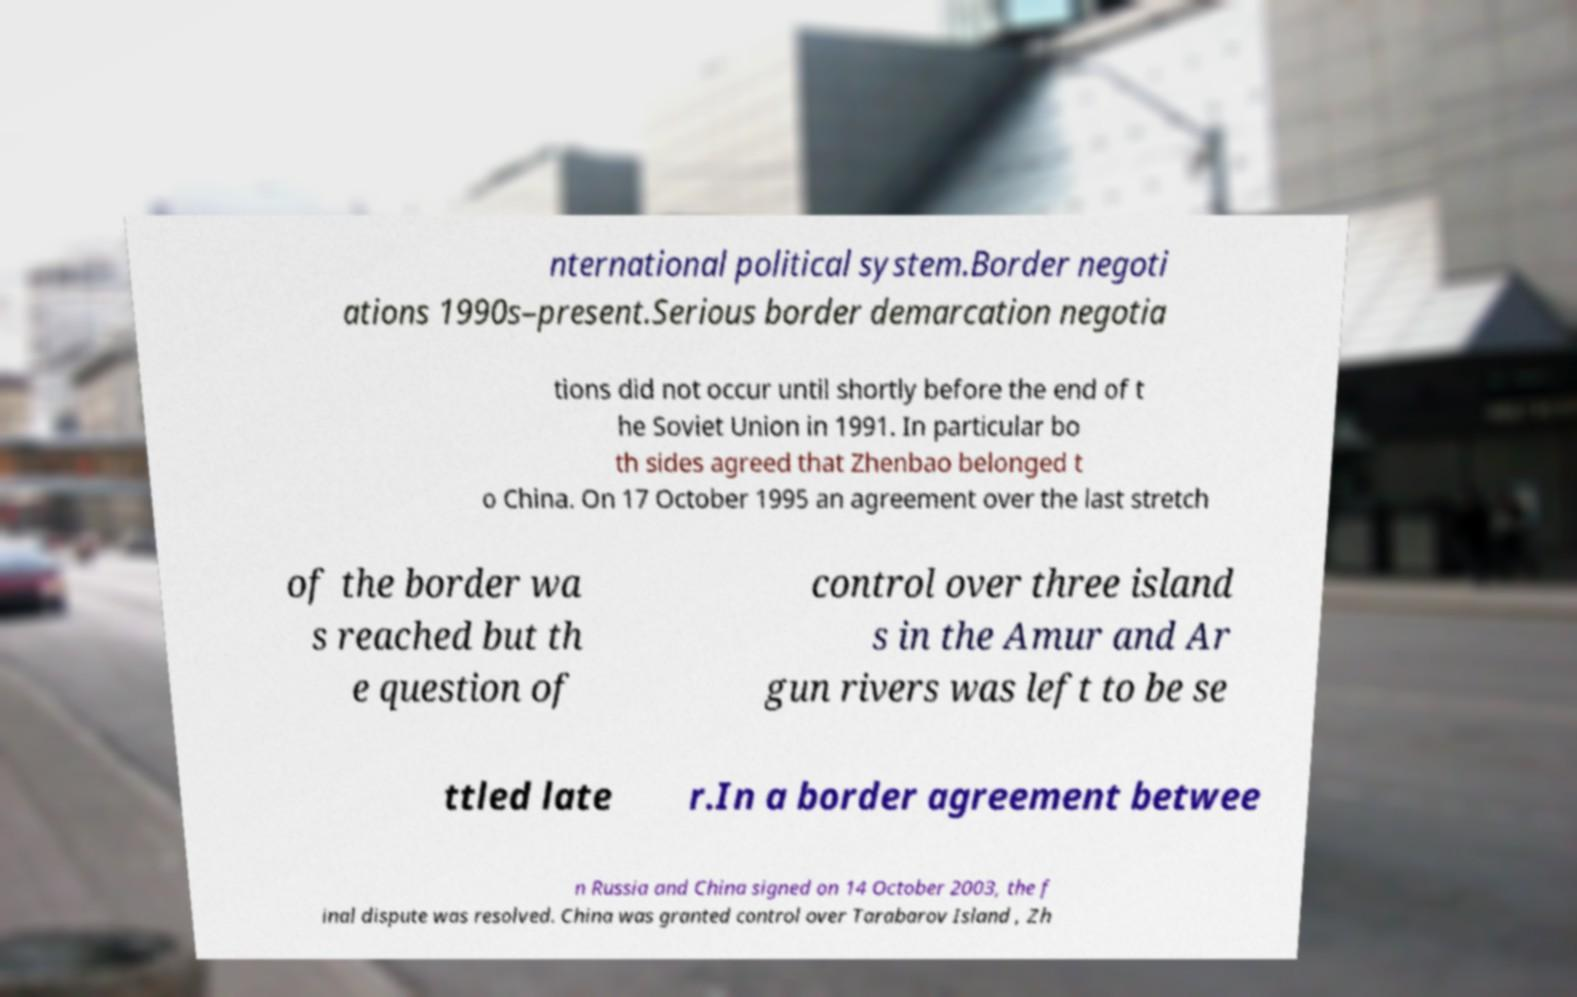There's text embedded in this image that I need extracted. Can you transcribe it verbatim? nternational political system.Border negoti ations 1990s–present.Serious border demarcation negotia tions did not occur until shortly before the end of t he Soviet Union in 1991. In particular bo th sides agreed that Zhenbao belonged t o China. On 17 October 1995 an agreement over the last stretch of the border wa s reached but th e question of control over three island s in the Amur and Ar gun rivers was left to be se ttled late r.In a border agreement betwee n Russia and China signed on 14 October 2003, the f inal dispute was resolved. China was granted control over Tarabarov Island , Zh 